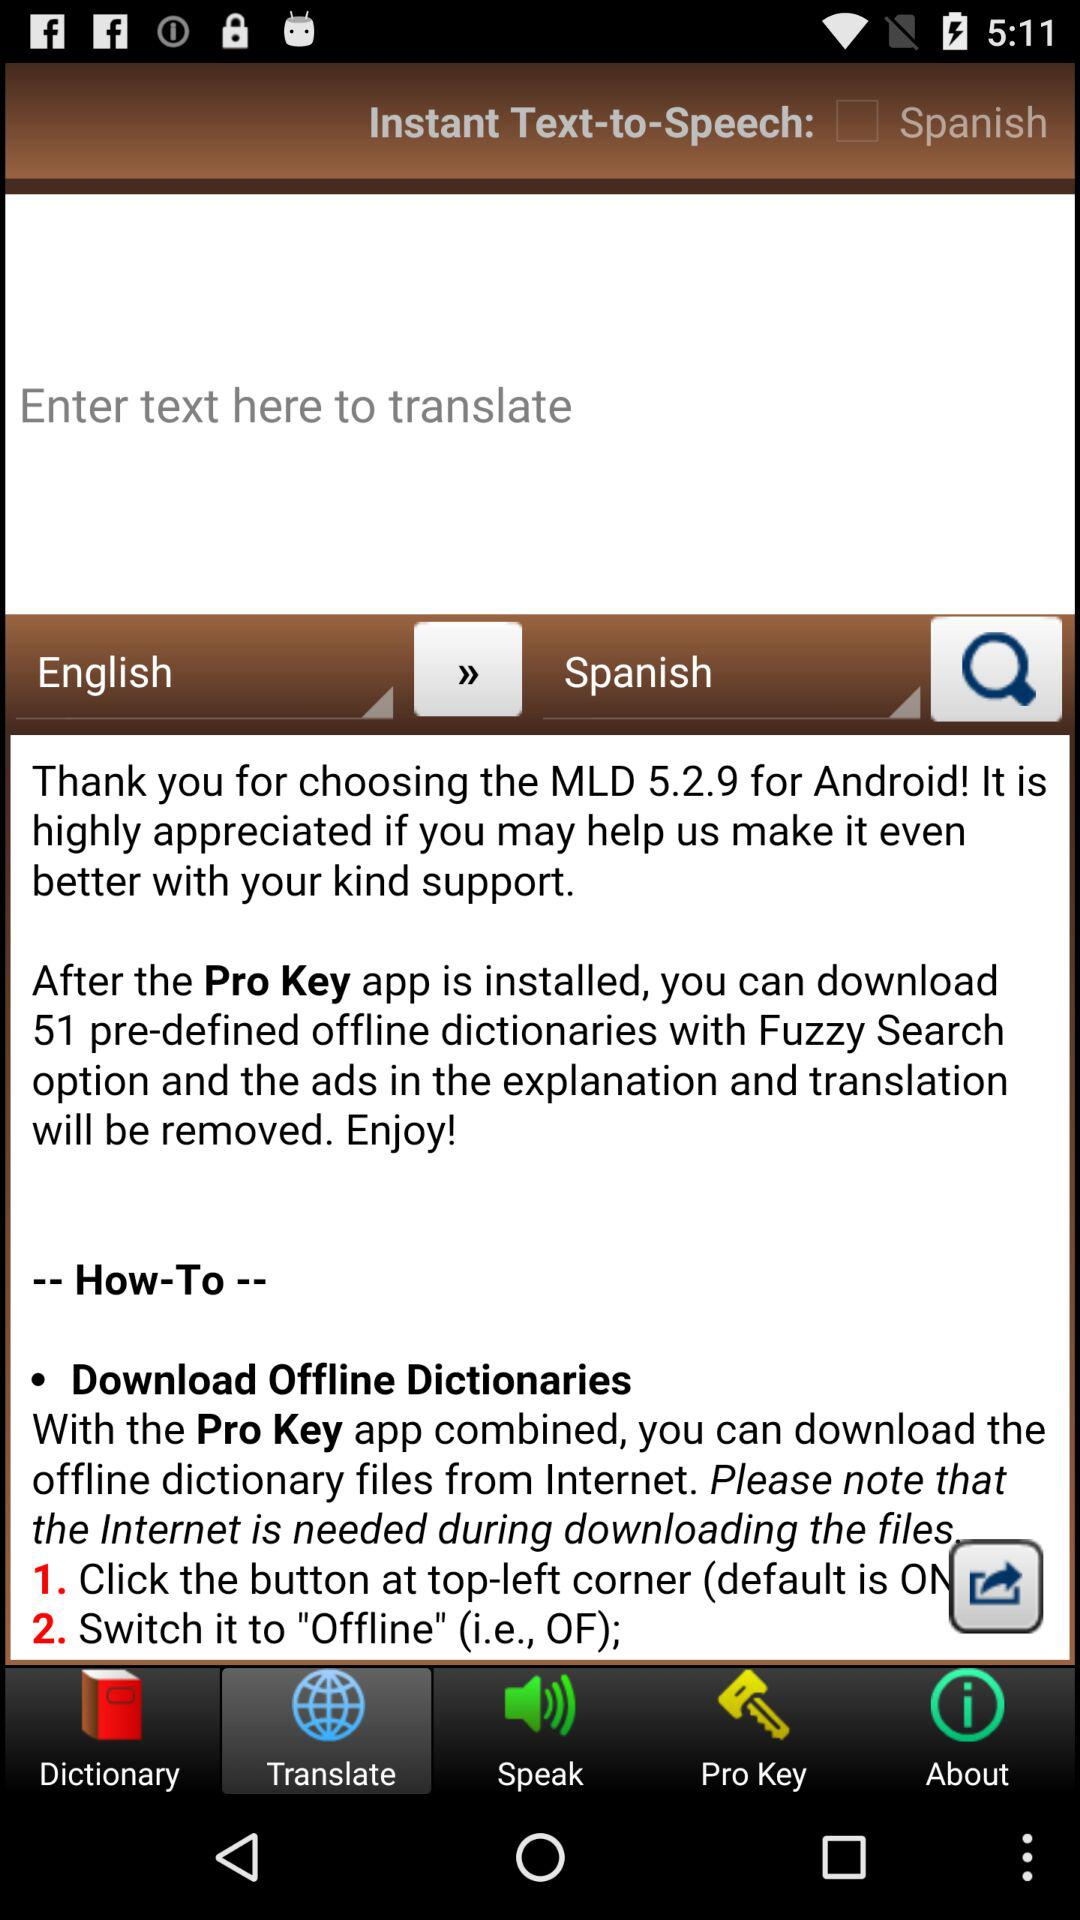How many dictionaries are available offline?
Answer the question using a single word or phrase. 51 